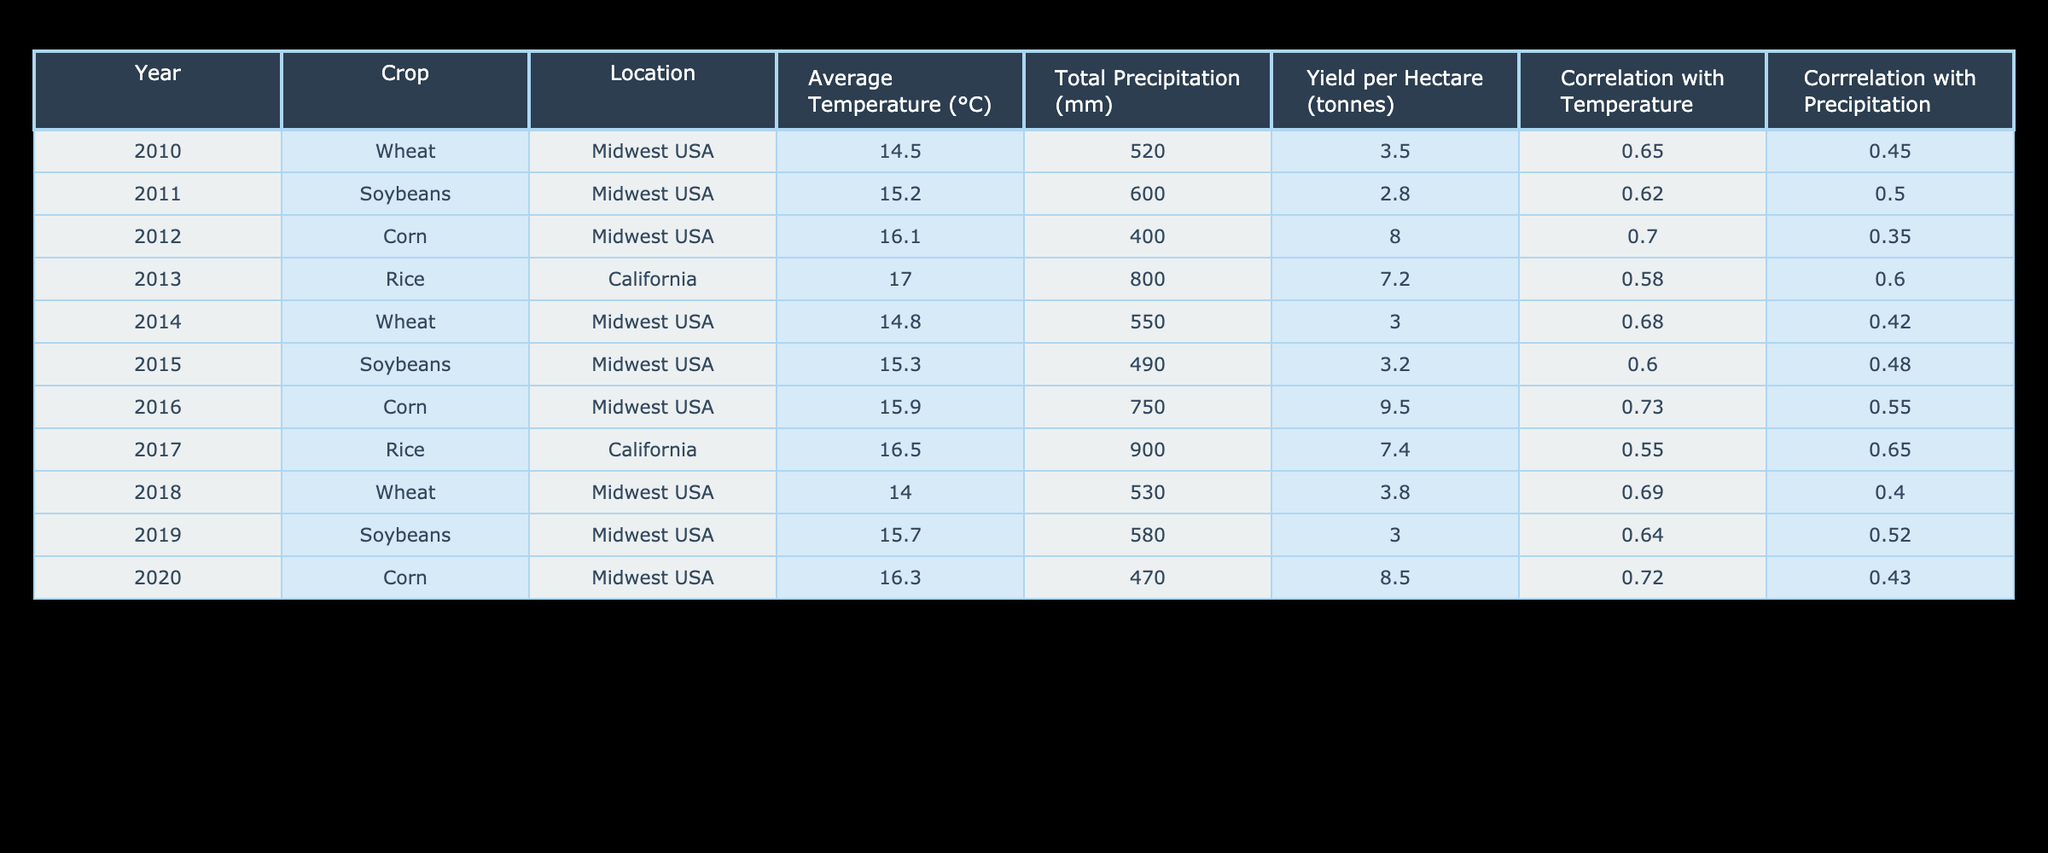What was the average yield per hectare for Wheat during the years provided? To find the average yield for Wheat, we gather the yield values for each year it is listed: 3.5 (2010), 3.0 (2014), and 3.8 (2018). The total yield is 3.5 + 3.0 + 3.8 = 10.3. Since there are 3 data points, we divide by 3: 10.3 / 3 = 3.43.
Answer: 3.43 In which year did Corn have the highest yield per hectare? Looking at the rows for Corn, the yields are 8.0 (2012), 9.5 (2016), and 8.5 (2020). The highest yield is 9.5 in 2016.
Answer: 2016 Is there a correlation above 0.7 between yield per hectare and temperature for any crops? Reviewing the correlation values with temperature, Corn in 2016 has a correlation of 0.73, which is above 0.7. Therefore, yes, there is a correlation above 0.7 for Corn in 2016.
Answer: Yes What is the difference in average precipitation between years 2010 and 2020? For 2010, total precipitation is 520 mm and for 2020 it is 470 mm. The difference is 520 - 470 = 50 mm.
Answer: 50 mm Which crop had the lowest correlation with precipitation and what was the value? Examining the correlation with precipitation values, the lowest value is for Corn in 2012, which has a correlation of 0.35.
Answer: Corn, 0.35 In terms of Average Temperature, which crop has the highest average value from 2010 to 2020? The average temperatures for each crop are calculated: Wheat (14.5, 14.8, 14.0), Soybeans (15.2, 15.3, 15.7), Corn (16.1, 15.9, 16.3), and Rice (17.0, 16.5). The highest average is for Rice, with an average temperature of 16.75°C.
Answer: Rice, 16.75°C Was there an increase in yield per hectare for Soybeans from 2011 to 2019? Checking the yield for Soybeans: 2.8 (2011) and 3.0 (2019), there is a small increase from 2.8 to 3.0, which confirms the increase.
Answer: Yes What crop had the second highest correlation with temperature in 2016? In 2016, the correlations are: Corn (0.73), Soybeans (not listed), Rice (not listed), and Wheat (not listed). Thus, the second highest correlation is not applicable as only Corn is listed for that year.
Answer: None listed 